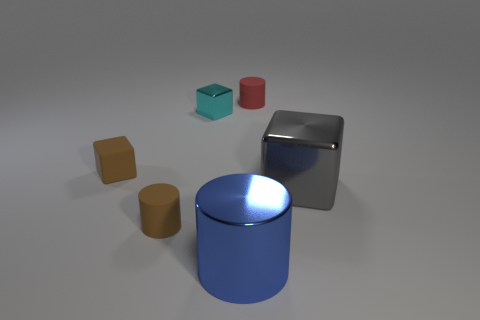Add 3 cylinders. How many objects exist? 9 Add 5 cubes. How many cubes exist? 8 Subtract 1 brown cylinders. How many objects are left? 5 Subtract all tiny gray spheres. Subtract all small metal objects. How many objects are left? 5 Add 3 big metal objects. How many big metal objects are left? 5 